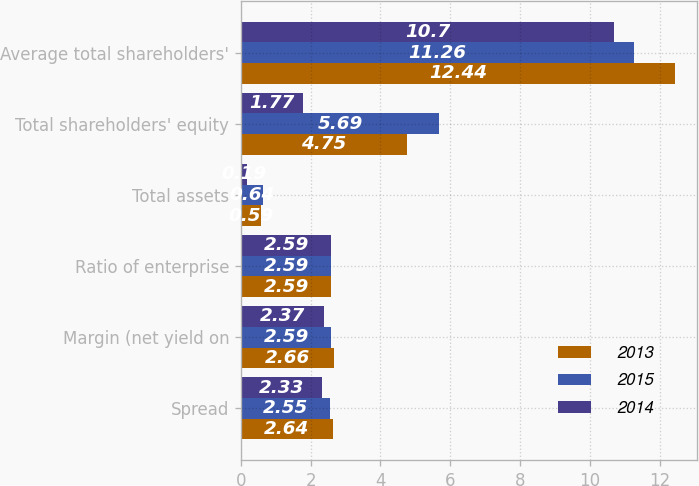Convert chart. <chart><loc_0><loc_0><loc_500><loc_500><stacked_bar_chart><ecel><fcel>Spread<fcel>Margin (net yield on<fcel>Ratio of enterprise<fcel>Total assets<fcel>Total shareholders' equity<fcel>Average total shareholders'<nl><fcel>2013<fcel>2.64<fcel>2.66<fcel>2.59<fcel>0.59<fcel>4.75<fcel>12.44<nl><fcel>2015<fcel>2.55<fcel>2.59<fcel>2.59<fcel>0.64<fcel>5.69<fcel>11.26<nl><fcel>2014<fcel>2.33<fcel>2.37<fcel>2.59<fcel>0.19<fcel>1.77<fcel>10.7<nl></chart> 